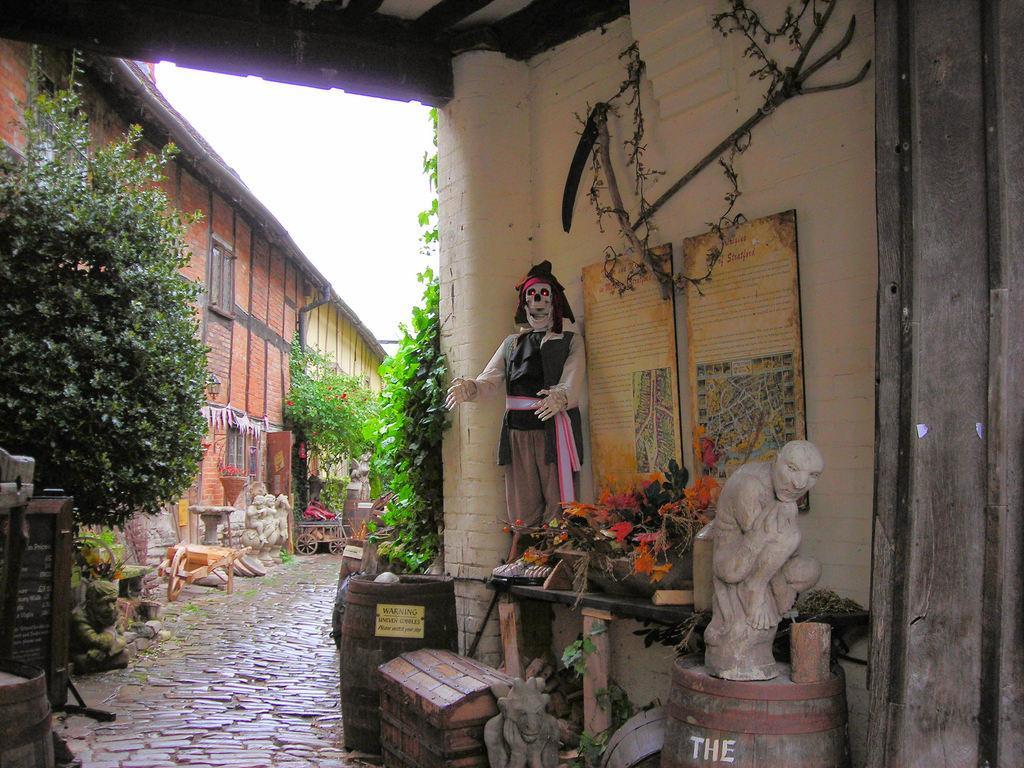Can you describe this image briefly? On the left side there is a tree, sculpture and a building. Also there are wooden objects, sculptures and plants. Near to the building there is a road. On the right side there is a building. On the wall there are frames. Also there is a platform. On that there is a skeleton. Also there are some decorative items. There is a barrel. On that there is a sculpture. Also there is a barrel and a box near to that. And there are many plants. In the background there is sky. 